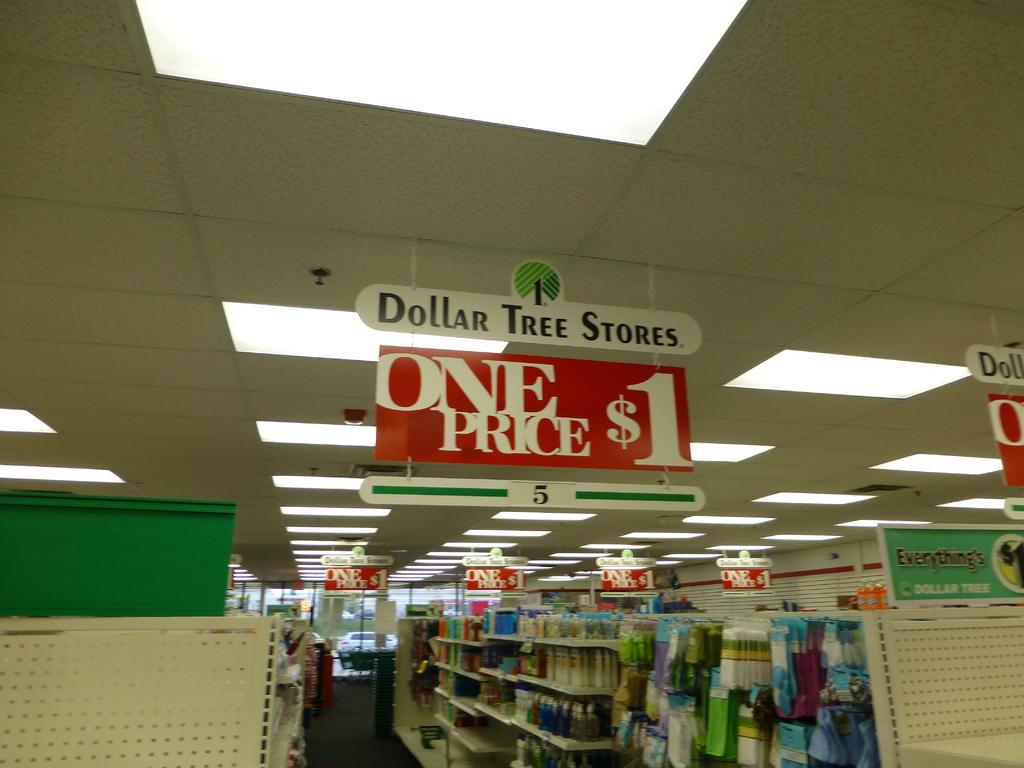<image>
Create a compact narrative representing the image presented. Everything in Dollar Tree Stores are only one dollar. 